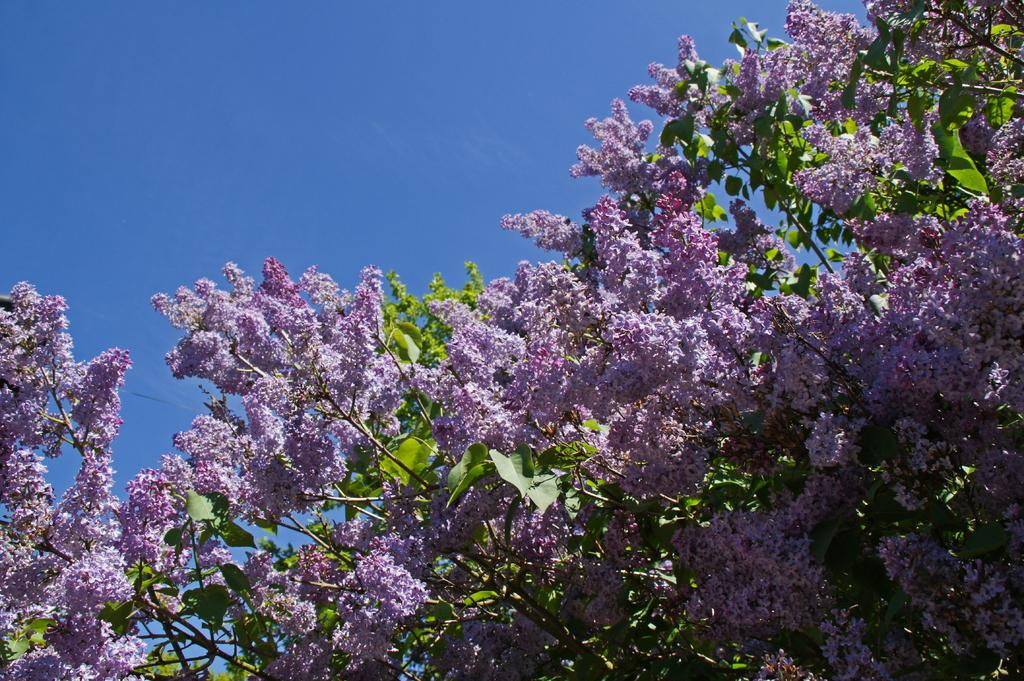What type of vegetation is present in the image? There are flowering trees in the image. What color are the leaves on the trees? There are green leaves in the image. What can be seen in the sky in the image? There are clouds in the sky in the image. What time is displayed on the clock in the image? There is no clock present in the image. What emotion can be seen on the faces of the people in the alley in the image? There are no people or alley present in the image; it features flowering trees, green leaves, and clouds in the sky. 